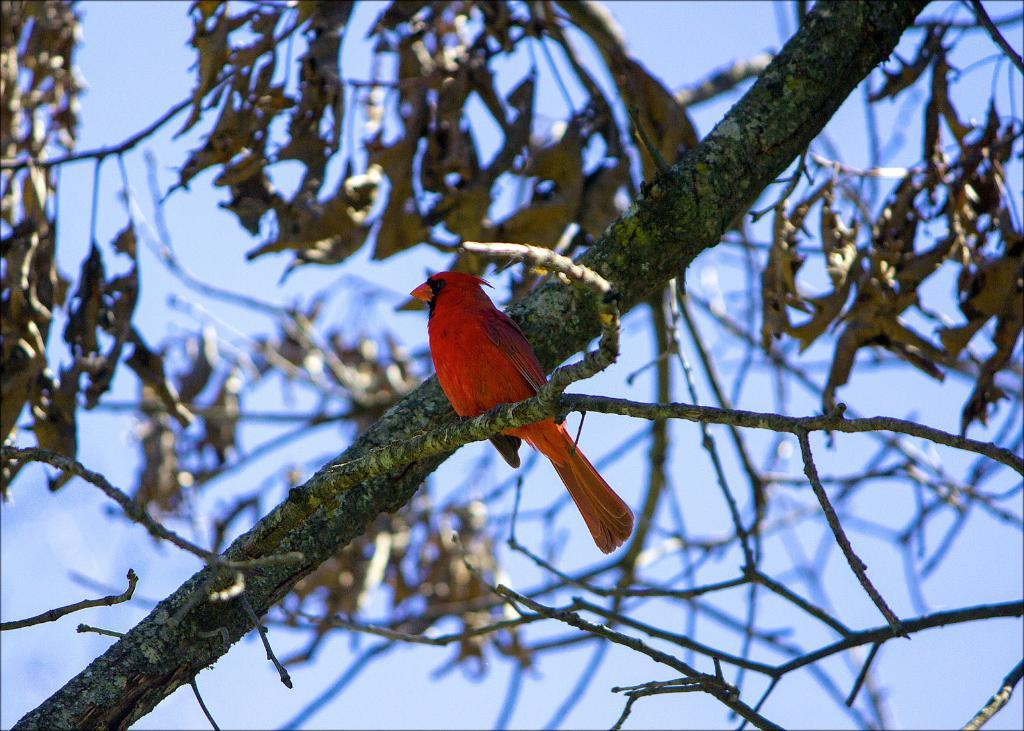What type of bird can be seen in the image? There is a red bird in the image. Where is the bird located? The bird is on a tree stem. What else can be seen on the tree in the image? Tree leaves are visible in the image. What is the condition of the background in the image? The background has a blurred view. What part of the natural environment is visible in the image? The sky is visible in the image. What type of bottle is hanging from the tree in the image? There is no bottle present in the image; it features a red bird on a tree stem with tree leaves and a blurred background. 